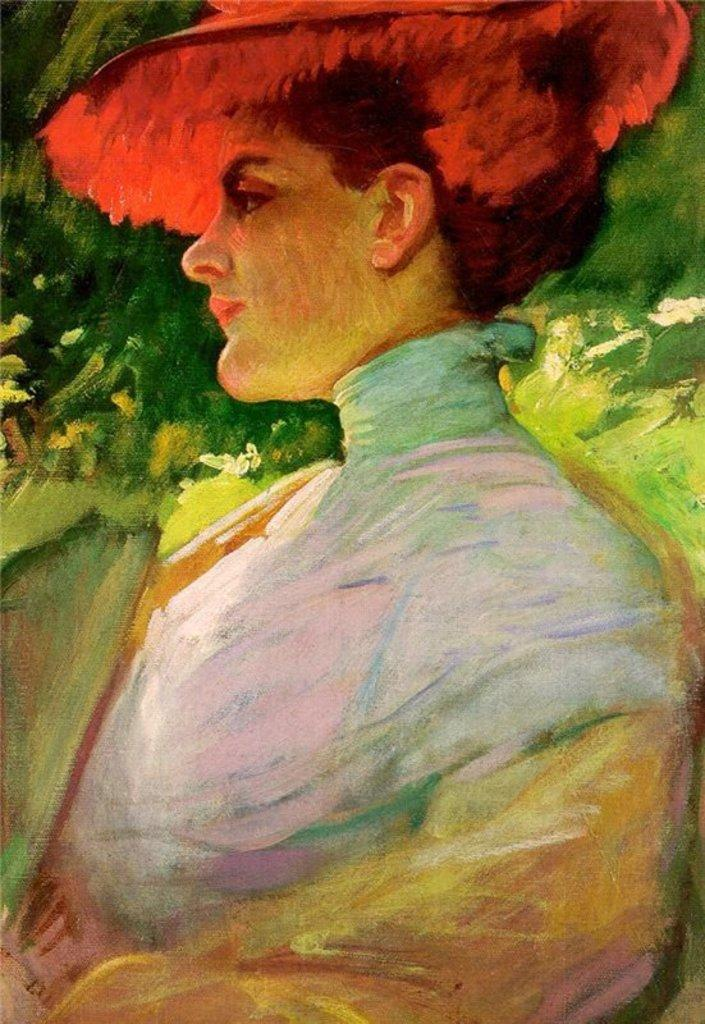What is the main subject of the image? There is a painting in the image. What is depicted in the painting? The painting contains a woman. What can be seen in the background of the painting? There are plants in the background of the painting. What type of sponge is being used by the woman in the painting? There is no sponge present in the painting, and the woman is not using any sponge. What time of day is depicted in the painting? The time of day is not specified in the painting, as it only shows a woman and plants in the background. 